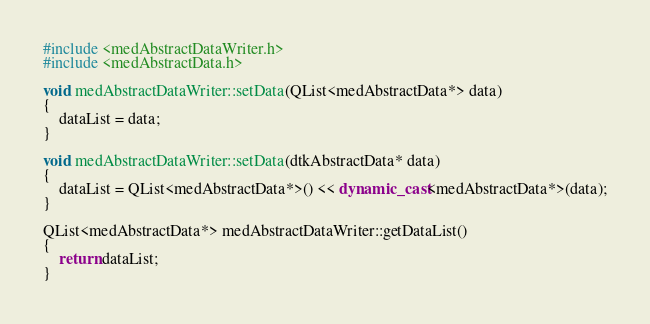<code> <loc_0><loc_0><loc_500><loc_500><_C++_>#include <medAbstractDataWriter.h>
#include <medAbstractData.h>

void medAbstractDataWriter::setData(QList<medAbstractData*> data)
{
	dataList = data;
}

void medAbstractDataWriter::setData(dtkAbstractData* data)
{
    dataList = QList<medAbstractData*>() << dynamic_cast<medAbstractData*>(data);
}

QList<medAbstractData*> medAbstractDataWriter::getDataList()
{
	return dataList;
}
</code> 